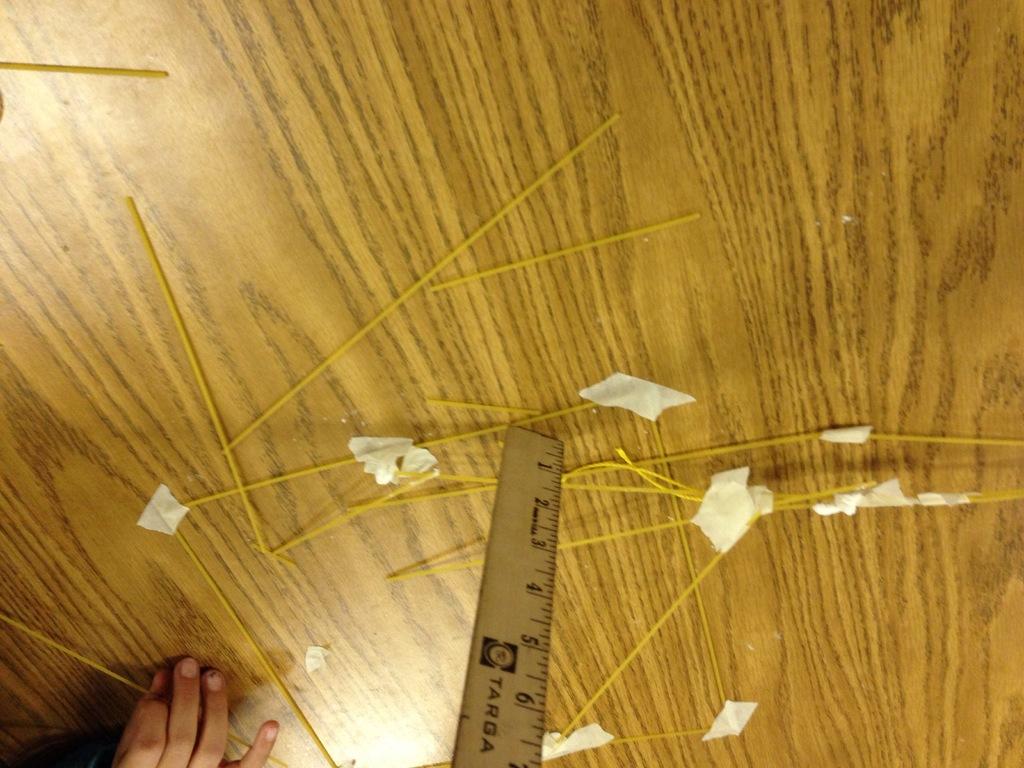Who makes this measuring tool?
Keep it short and to the point. Targa. 